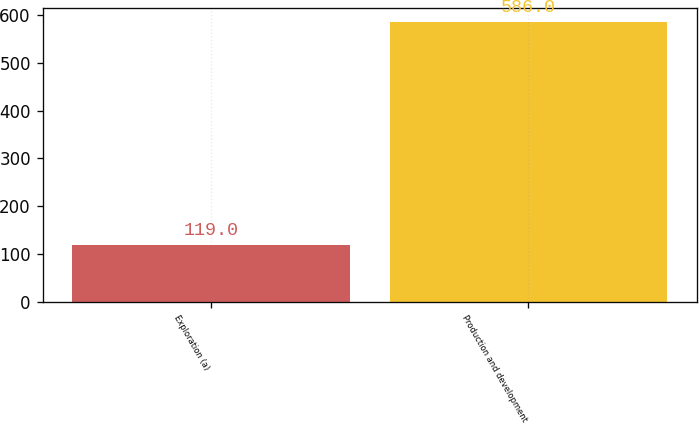Convert chart. <chart><loc_0><loc_0><loc_500><loc_500><bar_chart><fcel>Exploration (a)<fcel>Production and development<nl><fcel>119<fcel>586<nl></chart> 